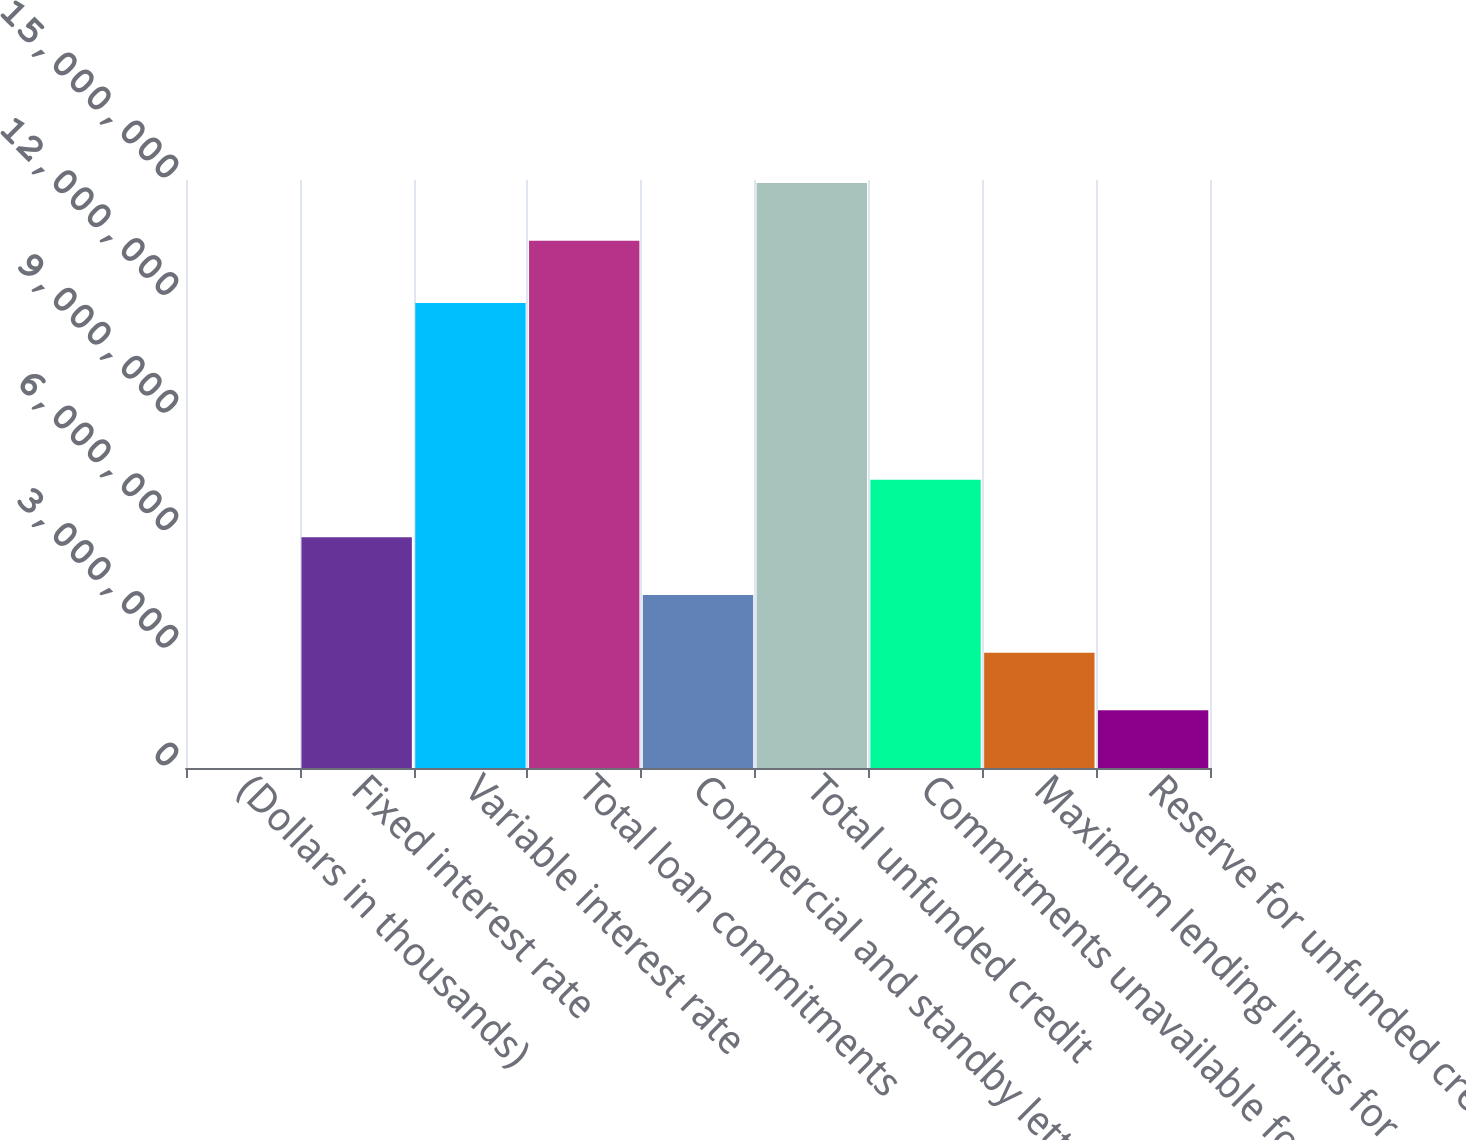<chart> <loc_0><loc_0><loc_500><loc_500><bar_chart><fcel>(Dollars in thousands)<fcel>Fixed interest rate<fcel>Variable interest rate<fcel>Total loan commitments<fcel>Commercial and standby letters<fcel>Total unfunded credit<fcel>Commitments unavailable for<fcel>Maximum lending limits for<fcel>Reserve for unfunded credit<nl><fcel>2014<fcel>5.88352e+06<fcel>1.186e+07<fcel>1.34514e+07<fcel>4.41315e+06<fcel>1.49218e+07<fcel>7.3539e+06<fcel>2.94277e+06<fcel>1.47239e+06<nl></chart> 